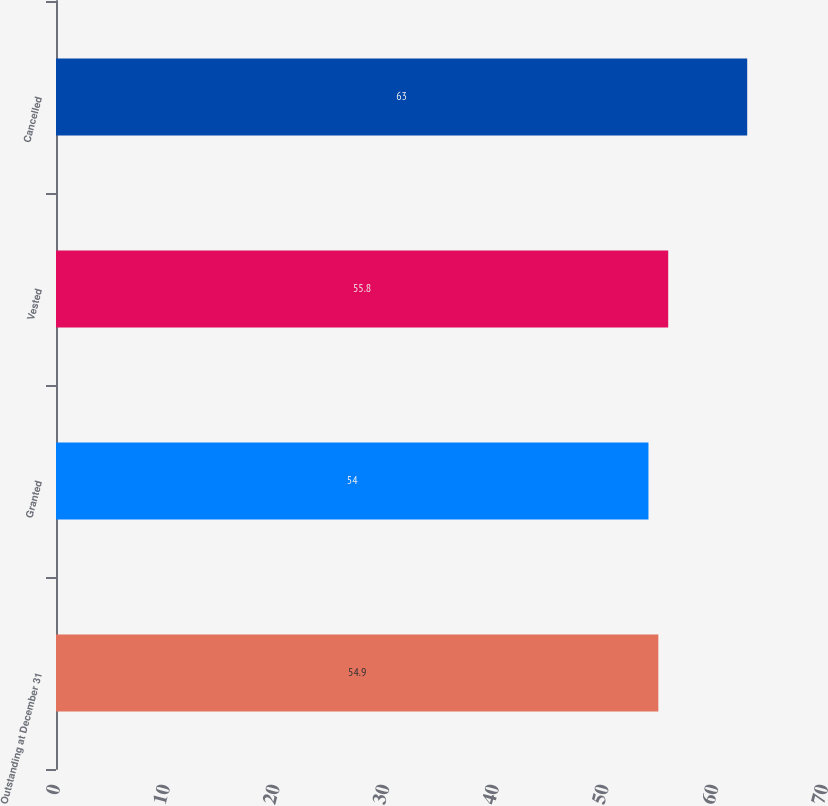Convert chart. <chart><loc_0><loc_0><loc_500><loc_500><bar_chart><fcel>Outstanding at December 31<fcel>Granted<fcel>Vested<fcel>Cancelled<nl><fcel>54.9<fcel>54<fcel>55.8<fcel>63<nl></chart> 